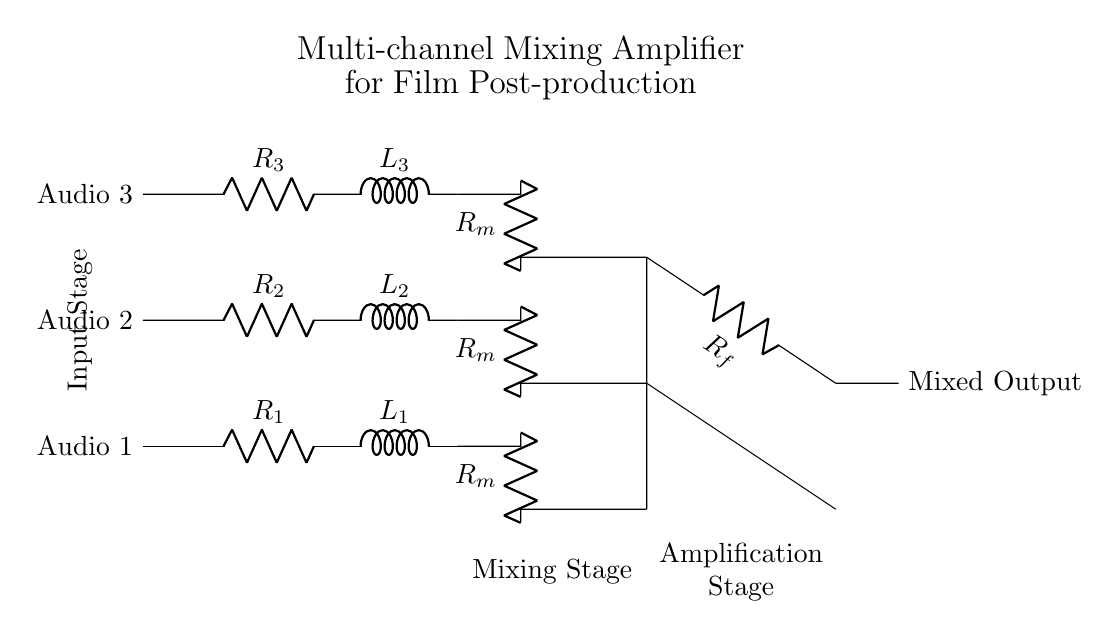What are the components in the input stage? The input stage contains three resistors (R1, R2, R3) and three inductors (L1, L2, L3) for Audio 1, Audio 2, and Audio 3.
Answer: Resistors and inductors What is the function of Rf in this circuit? Rf is the feedback resistor that helps control the gain of the operational amplifier, influencing how much output is fed back into the input.
Answer: Feedback How many audio inputs does this circuit have? The circuit has three audio inputs marked as Audio 1, Audio 2, and Audio 3.
Answer: Three inputs What type of amplifier is represented in this circuit? The circuit is a multi-channel mixing amplifier designed to combine multiple audio signals into one output.
Answer: Mixing amplifier Why is an operational amplifier used in this circuit? An operational amplifier provides the necessary gain to amplify the mixed audio signals, allowing for a balanced output.
Answer: Gain amplification What does the term "Mixed Output" refer to? The "Mixed Output" is the final combined audio signal that results from mixing the inputs through the amplifier stages.
Answer: Final combined signal 